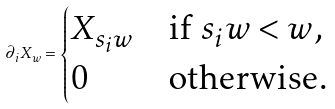<formula> <loc_0><loc_0><loc_500><loc_500>\partial _ { i } X _ { w } = \begin{cases} X _ { s _ { i } w } & \text {if $s_{i}w < w$,} \\ 0 & \text {otherwise.} \end{cases}</formula> 